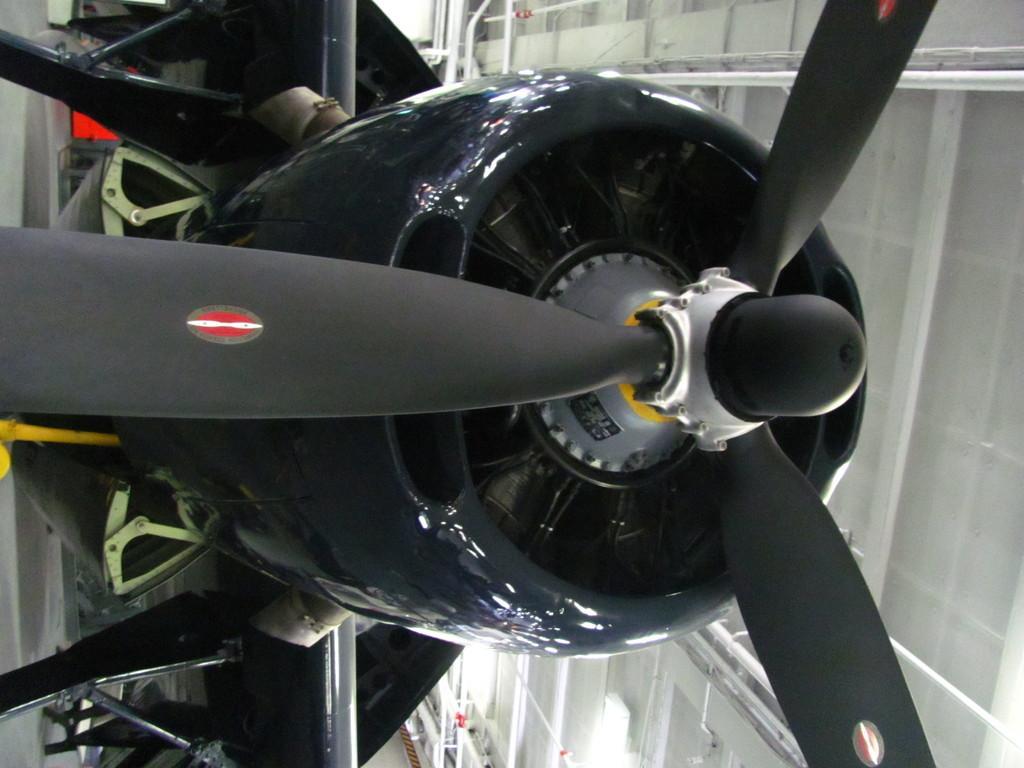Describe this image in one or two sentences. In this picture we can see a propeller engine and in the background we can see some objects. 